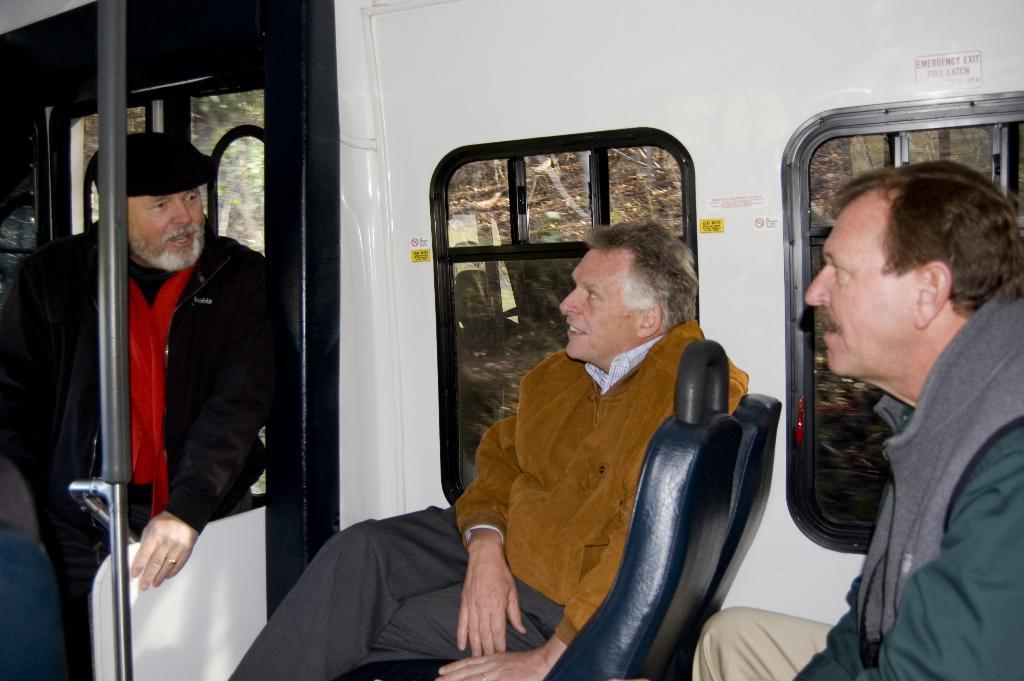What is the setting of the image? The image is taken inside a train. Where are the two persons sitting in relation to the window? They are sitting beside a window on the left side. What is the man in the image doing? There is a man standing in front of the window. What type of string can be seen tied to the window in the image? There is no string tied to the window in the image. Is there a desk visible in the image? There is no desk present in the image. 